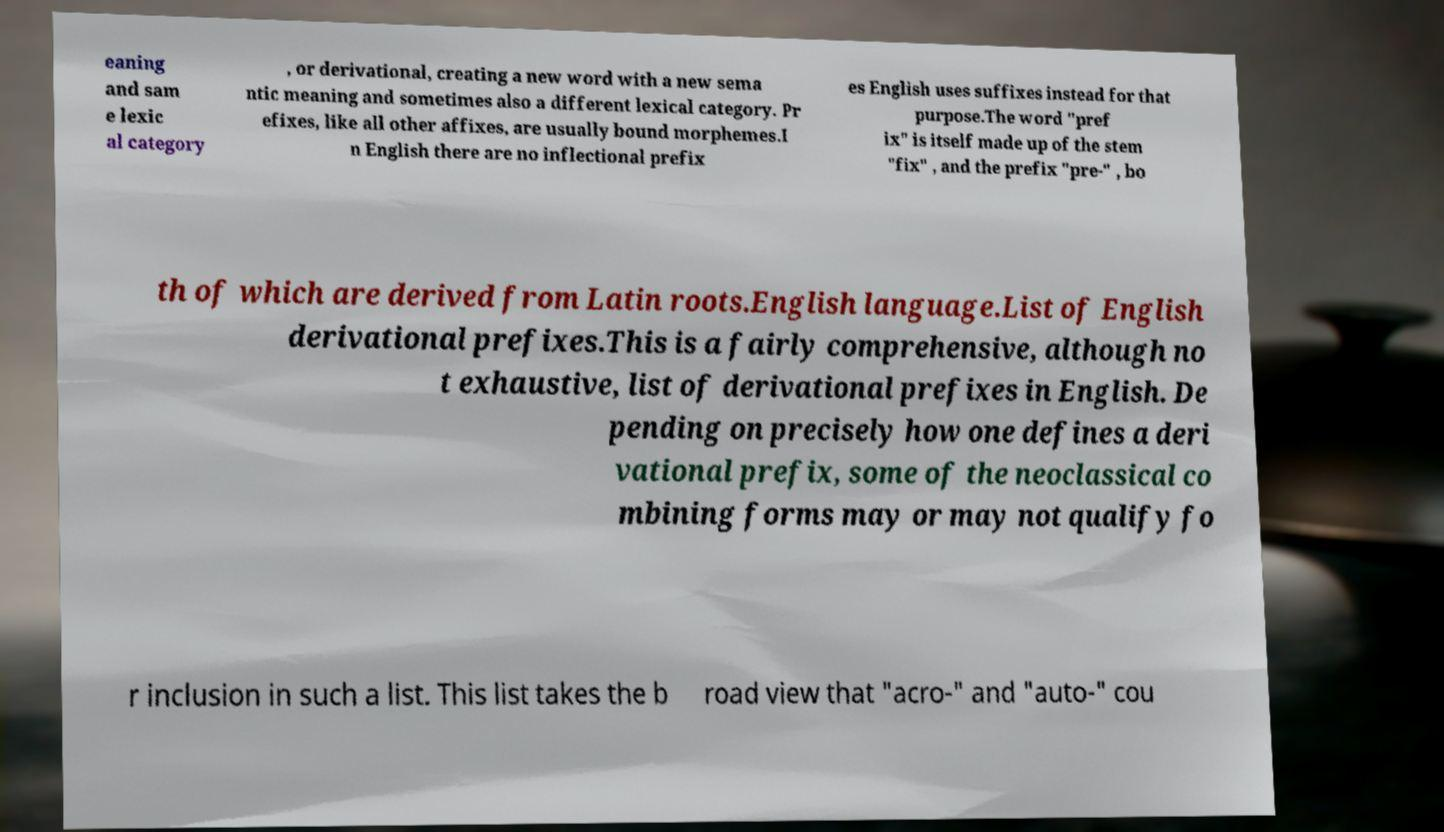Can you read and provide the text displayed in the image?This photo seems to have some interesting text. Can you extract and type it out for me? eaning and sam e lexic al category , or derivational, creating a new word with a new sema ntic meaning and sometimes also a different lexical category. Pr efixes, like all other affixes, are usually bound morphemes.I n English there are no inflectional prefix es English uses suffixes instead for that purpose.The word "pref ix" is itself made up of the stem "fix" , and the prefix "pre-" , bo th of which are derived from Latin roots.English language.List of English derivational prefixes.This is a fairly comprehensive, although no t exhaustive, list of derivational prefixes in English. De pending on precisely how one defines a deri vational prefix, some of the neoclassical co mbining forms may or may not qualify fo r inclusion in such a list. This list takes the b road view that "acro-" and "auto-" cou 